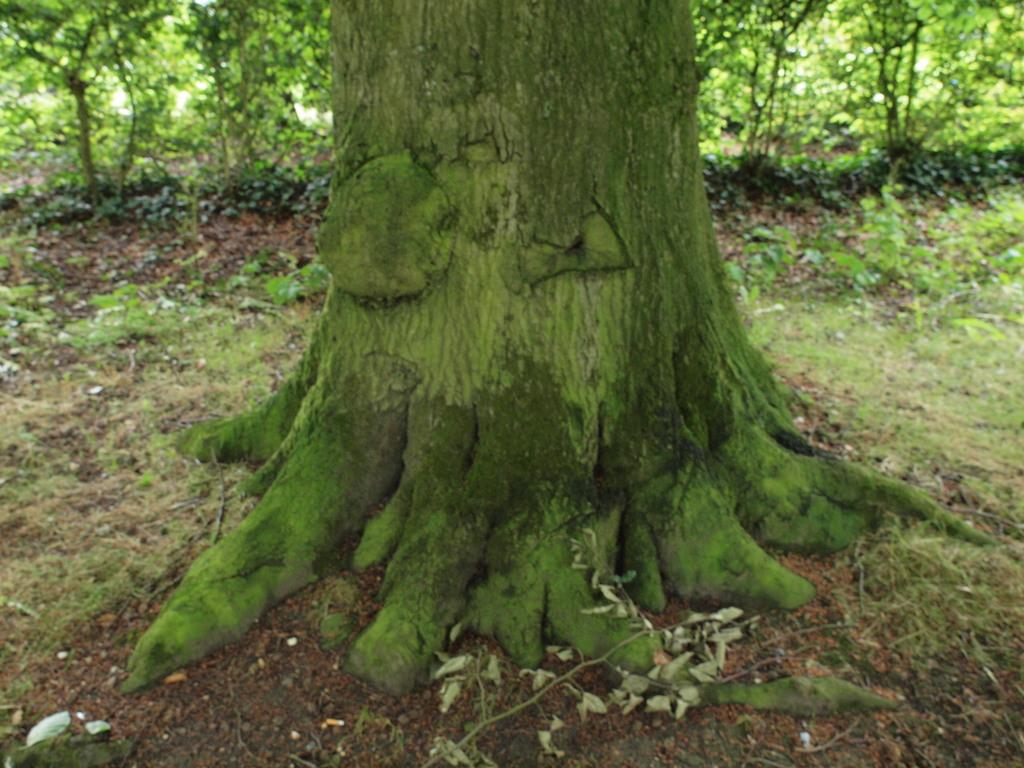What is the main subject of the image? The main subject of the image is a tree trunk. Can you describe the background of the image? There are trees in the background of the image. What type of silk fabric is draped over the tree trunk in the image? There is no silk fabric present in the image; it only features a tree trunk and trees in the background. 